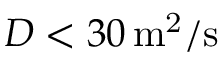<formula> <loc_0><loc_0><loc_500><loc_500>D < 3 0 \, m ^ { 2 } / s</formula> 